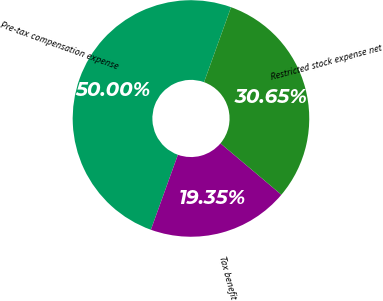Convert chart. <chart><loc_0><loc_0><loc_500><loc_500><pie_chart><fcel>Pre-tax compensation expense<fcel>Tax benefit<fcel>Restricted stock expense net<nl><fcel>50.0%<fcel>19.35%<fcel>30.65%<nl></chart> 